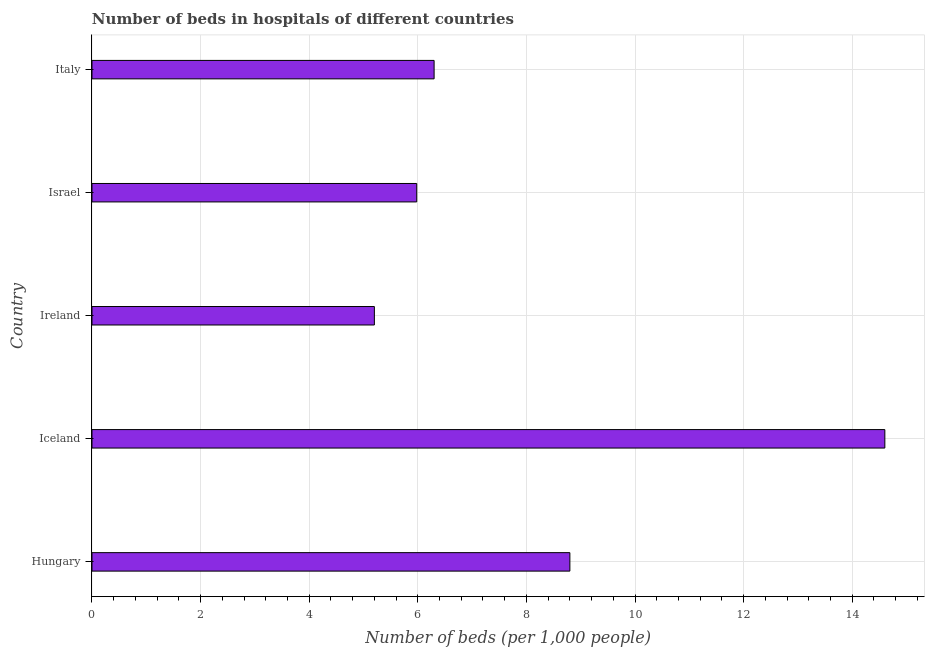What is the title of the graph?
Offer a terse response. Number of beds in hospitals of different countries. What is the label or title of the X-axis?
Make the answer very short. Number of beds (per 1,0 people). What is the number of hospital beds in Ireland?
Keep it short and to the point. 5.2. Across all countries, what is the maximum number of hospital beds?
Offer a very short reply. 14.6. Across all countries, what is the minimum number of hospital beds?
Your response must be concise. 5.2. In which country was the number of hospital beds minimum?
Keep it short and to the point. Ireland. What is the sum of the number of hospital beds?
Offer a terse response. 40.88. What is the average number of hospital beds per country?
Keep it short and to the point. 8.18. What is the median number of hospital beds?
Your answer should be compact. 6.3. What is the ratio of the number of hospital beds in Ireland to that in Israel?
Provide a succinct answer. 0.87. Is the difference between the number of hospital beds in Hungary and Ireland greater than the difference between any two countries?
Offer a terse response. No. What is the difference between the highest and the lowest number of hospital beds?
Ensure brevity in your answer.  9.4. Are all the bars in the graph horizontal?
Keep it short and to the point. Yes. How many countries are there in the graph?
Ensure brevity in your answer.  5. What is the difference between two consecutive major ticks on the X-axis?
Make the answer very short. 2. Are the values on the major ticks of X-axis written in scientific E-notation?
Your answer should be very brief. No. What is the Number of beds (per 1,000 people) of Hungary?
Your answer should be compact. 8.8. What is the Number of beds (per 1,000 people) of Iceland?
Provide a succinct answer. 14.6. What is the Number of beds (per 1,000 people) in Ireland?
Keep it short and to the point. 5.2. What is the Number of beds (per 1,000 people) of Israel?
Your answer should be very brief. 5.98. What is the Number of beds (per 1,000 people) in Italy?
Provide a succinct answer. 6.3. What is the difference between the Number of beds (per 1,000 people) in Hungary and Ireland?
Make the answer very short. 3.6. What is the difference between the Number of beds (per 1,000 people) in Hungary and Israel?
Make the answer very short. 2.82. What is the difference between the Number of beds (per 1,000 people) in Iceland and Israel?
Your response must be concise. 8.62. What is the difference between the Number of beds (per 1,000 people) in Ireland and Israel?
Provide a short and direct response. -0.78. What is the difference between the Number of beds (per 1,000 people) in Israel and Italy?
Make the answer very short. -0.32. What is the ratio of the Number of beds (per 1,000 people) in Hungary to that in Iceland?
Provide a succinct answer. 0.6. What is the ratio of the Number of beds (per 1,000 people) in Hungary to that in Ireland?
Offer a very short reply. 1.69. What is the ratio of the Number of beds (per 1,000 people) in Hungary to that in Israel?
Ensure brevity in your answer.  1.47. What is the ratio of the Number of beds (per 1,000 people) in Hungary to that in Italy?
Give a very brief answer. 1.4. What is the ratio of the Number of beds (per 1,000 people) in Iceland to that in Ireland?
Your answer should be very brief. 2.81. What is the ratio of the Number of beds (per 1,000 people) in Iceland to that in Israel?
Provide a short and direct response. 2.44. What is the ratio of the Number of beds (per 1,000 people) in Iceland to that in Italy?
Give a very brief answer. 2.32. What is the ratio of the Number of beds (per 1,000 people) in Ireland to that in Israel?
Make the answer very short. 0.87. What is the ratio of the Number of beds (per 1,000 people) in Ireland to that in Italy?
Offer a terse response. 0.82. What is the ratio of the Number of beds (per 1,000 people) in Israel to that in Italy?
Your answer should be compact. 0.95. 